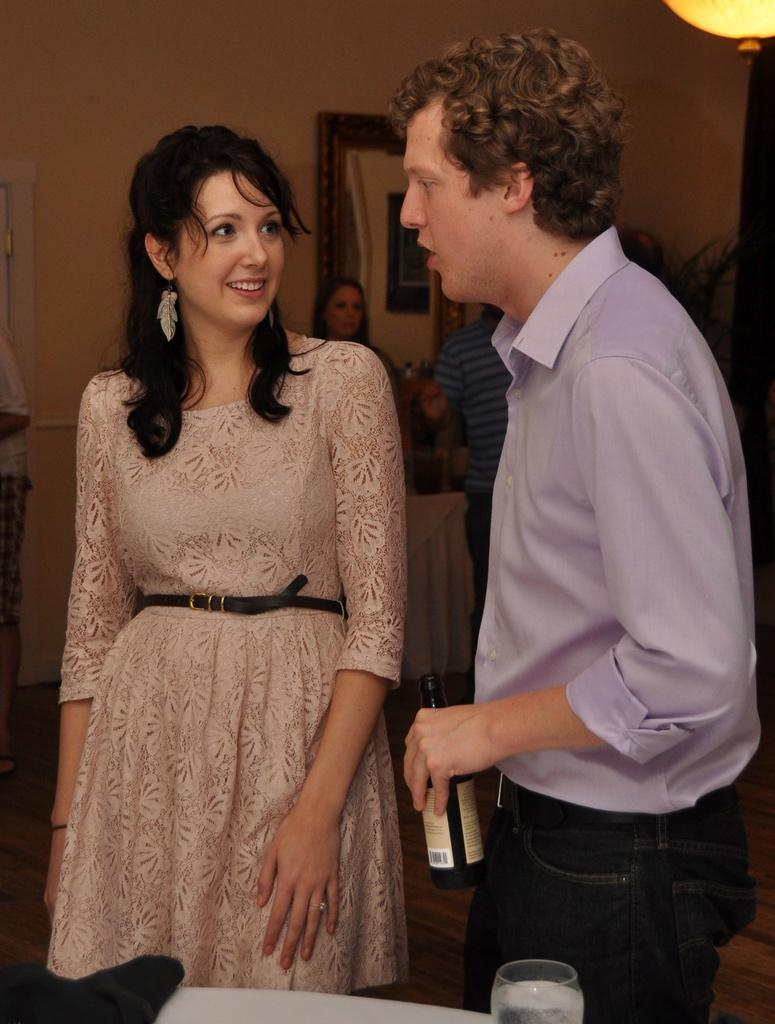What are the two persons in the image doing? The two persons in the image are talking with each other. Can you describe the gender of the two persons? One of the persons is a man, and the other person is a woman. What is the man holding in the image? The man is holding a beer bottle. What else can be seen in the background of the image? There are other people in the background. What type of dog is sitting next to the man in the image? There is no dog present in the image; it only features two persons talking with each other. How does the man's nerve affect his conversation with the woman in the image? The provided facts do not mention anything about the man's nerves or emotions, so we cannot determine how they might affect the conversation. 